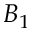<formula> <loc_0><loc_0><loc_500><loc_500>B _ { 1 }</formula> 